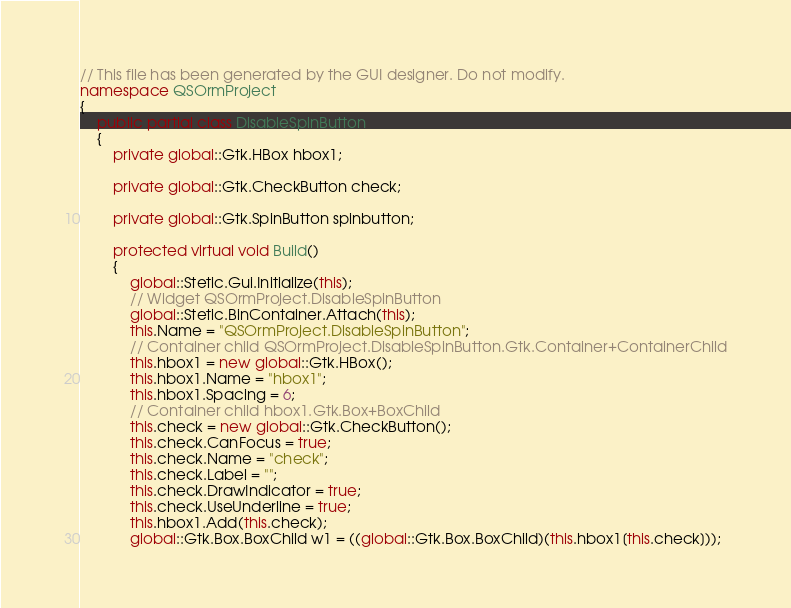Convert code to text. <code><loc_0><loc_0><loc_500><loc_500><_C#_>
// This file has been generated by the GUI designer. Do not modify.
namespace QSOrmProject
{
	public partial class DisableSpinButton
	{
		private global::Gtk.HBox hbox1;

		private global::Gtk.CheckButton check;

		private global::Gtk.SpinButton spinbutton;

		protected virtual void Build()
		{
			global::Stetic.Gui.Initialize(this);
			// Widget QSOrmProject.DisableSpinButton
			global::Stetic.BinContainer.Attach(this);
			this.Name = "QSOrmProject.DisableSpinButton";
			// Container child QSOrmProject.DisableSpinButton.Gtk.Container+ContainerChild
			this.hbox1 = new global::Gtk.HBox();
			this.hbox1.Name = "hbox1";
			this.hbox1.Spacing = 6;
			// Container child hbox1.Gtk.Box+BoxChild
			this.check = new global::Gtk.CheckButton();
			this.check.CanFocus = true;
			this.check.Name = "check";
			this.check.Label = "";
			this.check.DrawIndicator = true;
			this.check.UseUnderline = true;
			this.hbox1.Add(this.check);
			global::Gtk.Box.BoxChild w1 = ((global::Gtk.Box.BoxChild)(this.hbox1[this.check]));</code> 